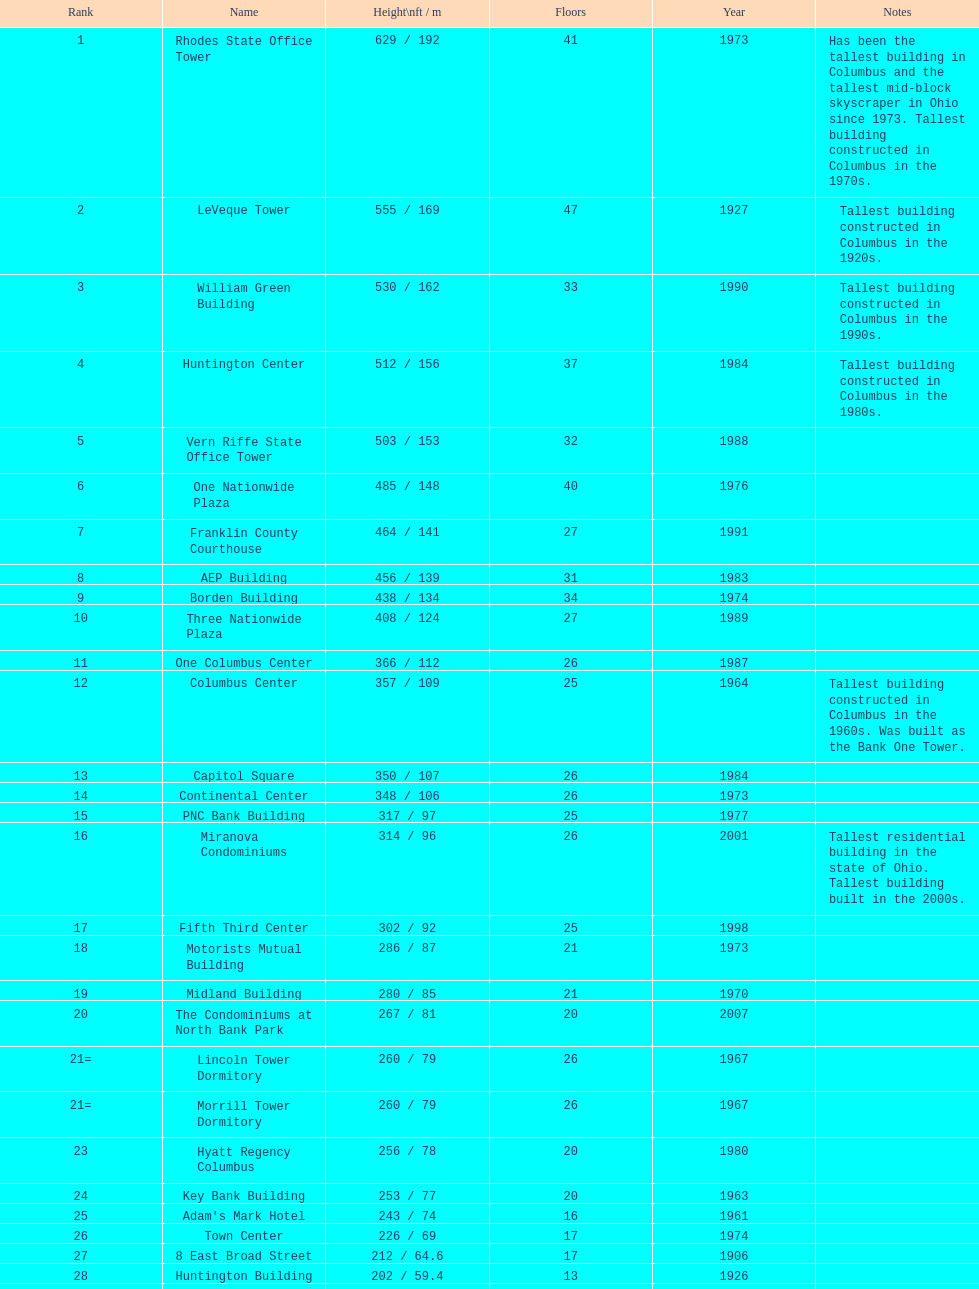On this table, what is the count of buildings that stand taller than 450 feet? 8. 